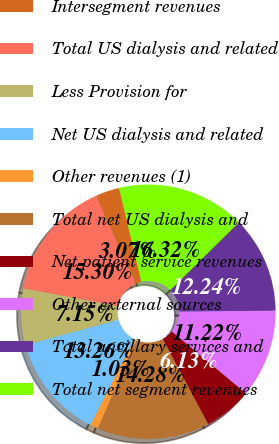<chart> <loc_0><loc_0><loc_500><loc_500><pie_chart><fcel>Intersegment revenues<fcel>Total US dialysis and related<fcel>Less Provision for<fcel>Net US dialysis and related<fcel>Other revenues (1)<fcel>Total net US dialysis and<fcel>Net patient service revenues<fcel>Other external sources<fcel>Total ancillary services and<fcel>Total net segment revenues<nl><fcel>3.07%<fcel>15.3%<fcel>7.15%<fcel>13.26%<fcel>1.03%<fcel>14.28%<fcel>6.13%<fcel>11.22%<fcel>12.24%<fcel>16.32%<nl></chart> 